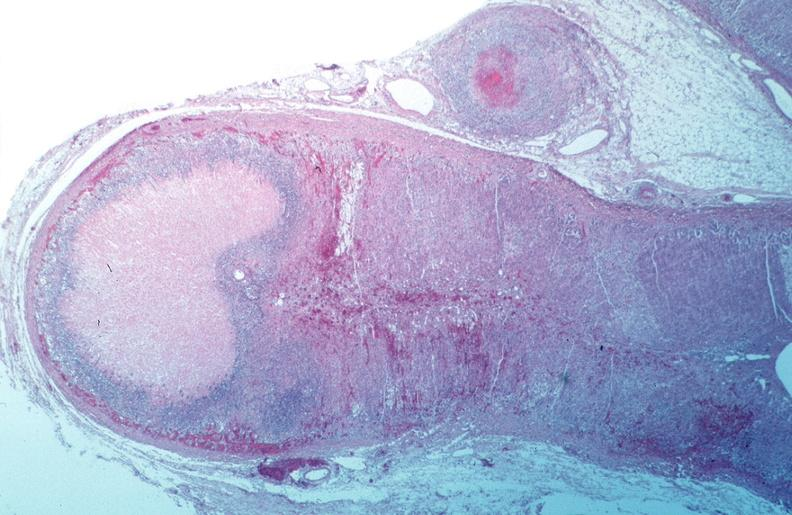what is present?
Answer the question using a single word or phrase. Cardiovascular 